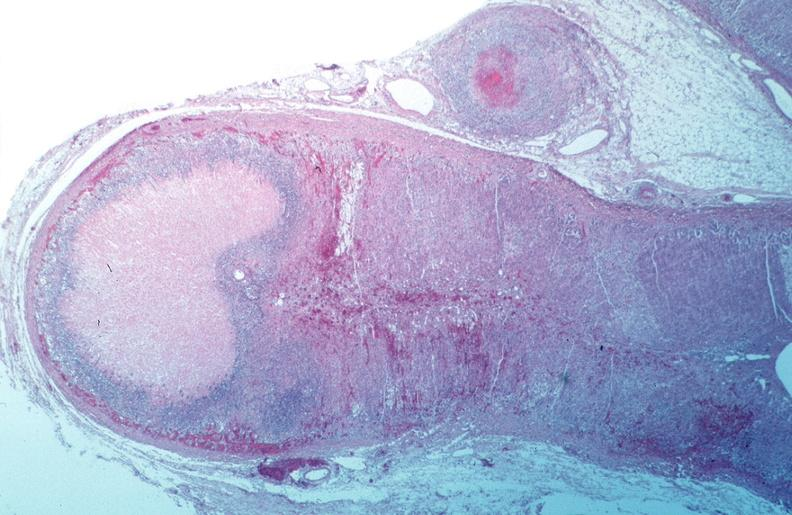what is present?
Answer the question using a single word or phrase. Cardiovascular 